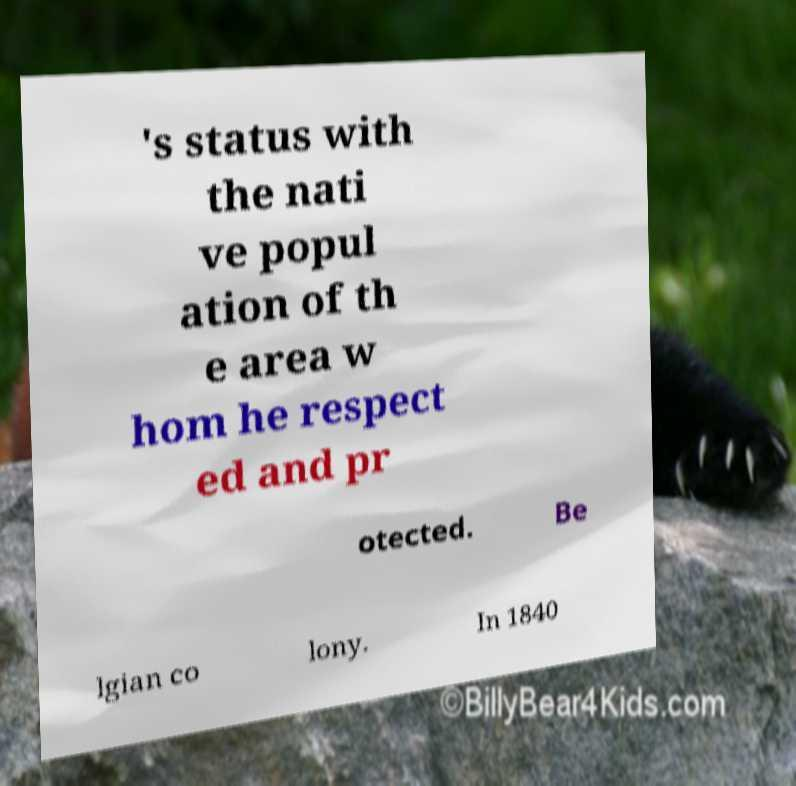Can you read and provide the text displayed in the image?This photo seems to have some interesting text. Can you extract and type it out for me? 's status with the nati ve popul ation of th e area w hom he respect ed and pr otected. Be lgian co lony. In 1840 